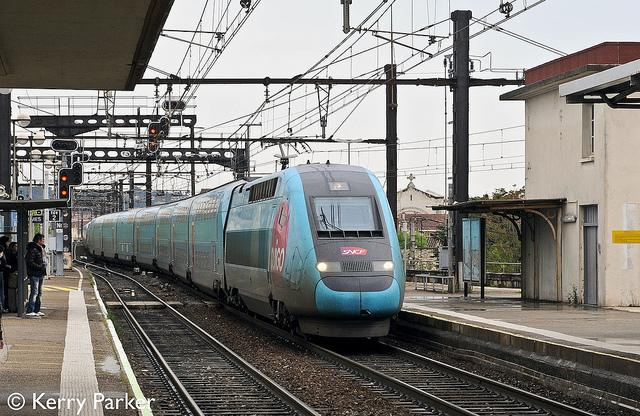The main color of this vehicle is the same color as what? Please explain your reasoning. sky. The bus is blue. 